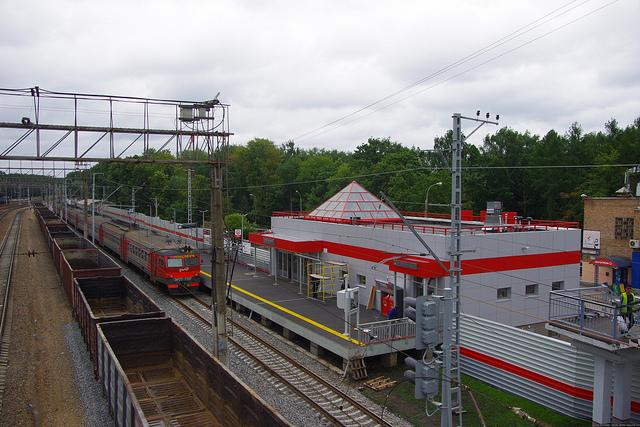These walls have a similar color scheme to what place? target 